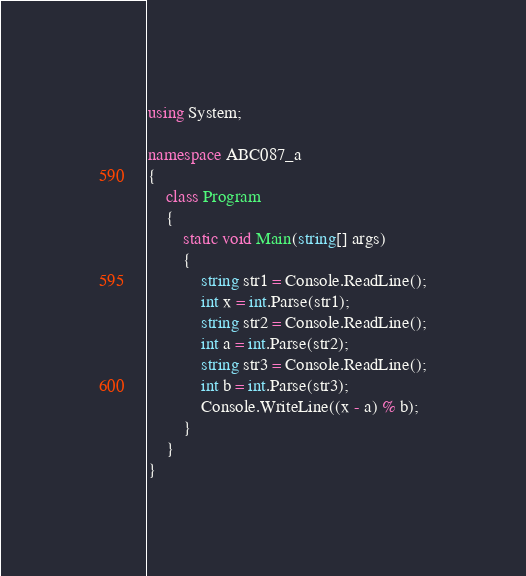Convert code to text. <code><loc_0><loc_0><loc_500><loc_500><_C#_>using System;

namespace ABC087_a
{
    class Program
    {
        static void Main(string[] args)
        {
            string str1 = Console.ReadLine();
            int x = int.Parse(str1);
            string str2 = Console.ReadLine();
            int a = int.Parse(str2);
            string str3 = Console.ReadLine();
            int b = int.Parse(str3);
            Console.WriteLine((x - a) % b);
        }
    }
}
</code> 